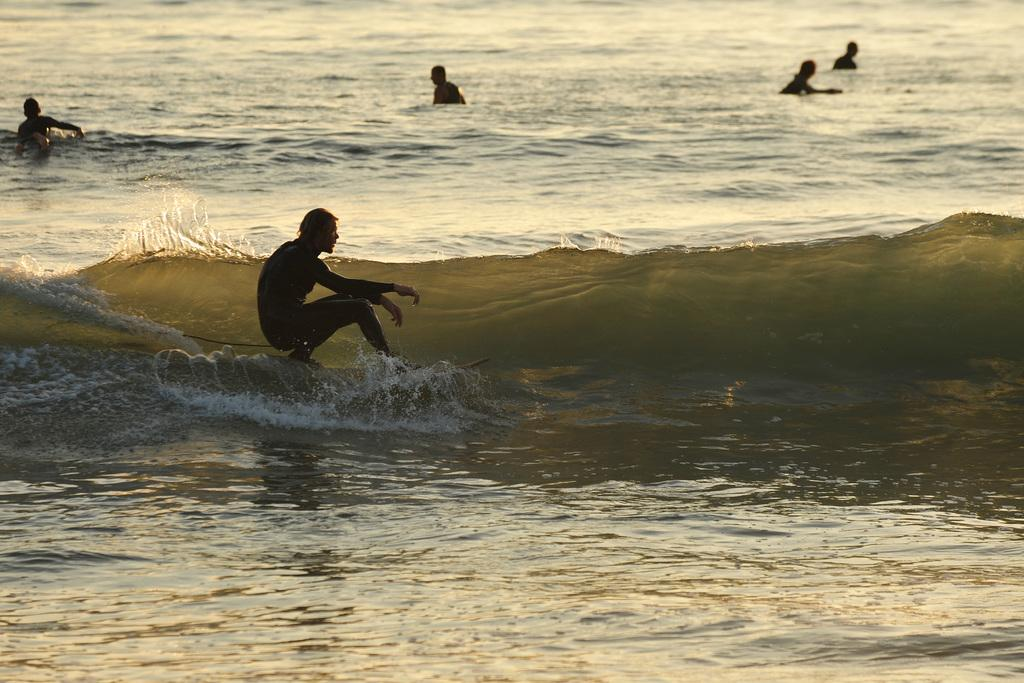What is the main subject of the image? There is a person on a surfboard in the image. What is the surfboard resting on? The surfboard is on water. Are there any other people visible in the image? Yes, there are four persons in the water in the background of the image. What type of copy is being made by the person on the surfboard? There is no copy being made by the person on the surfboard, as they are surfing on water. Can you hear the sound of the slope in the image? There is no slope present in the image, and therefore no sound associated with it can be heard. 